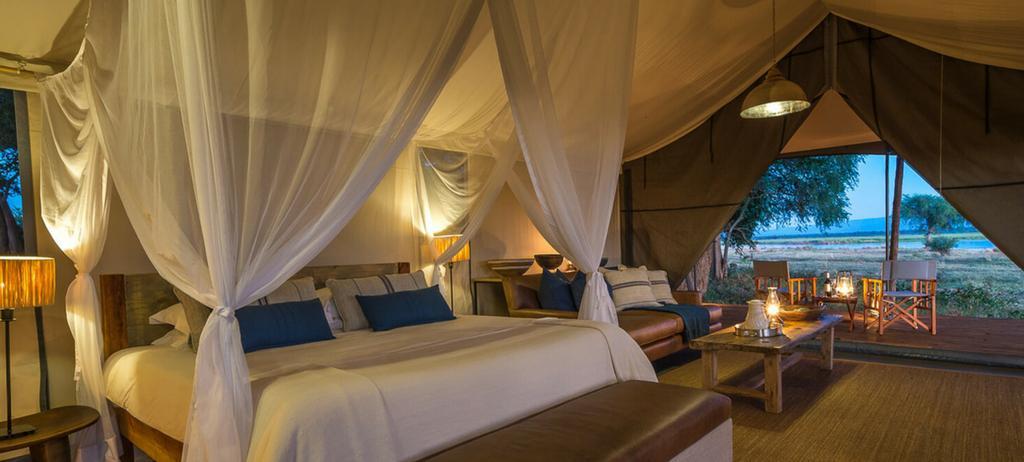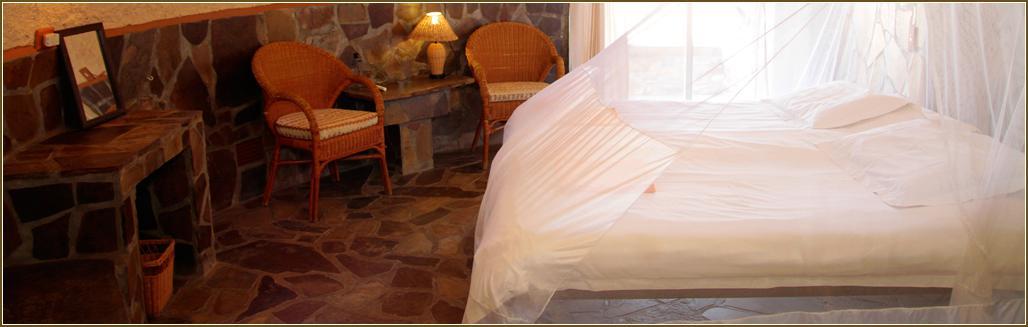The first image is the image on the left, the second image is the image on the right. For the images shown, is this caption "Two blue pillows are on a bed under a sheer white canopy that ties at the corners." true? Answer yes or no. Yes. The first image is the image on the left, the second image is the image on the right. For the images displayed, is the sentence "There is no more than 5 pillows." factually correct? Answer yes or no. No. 